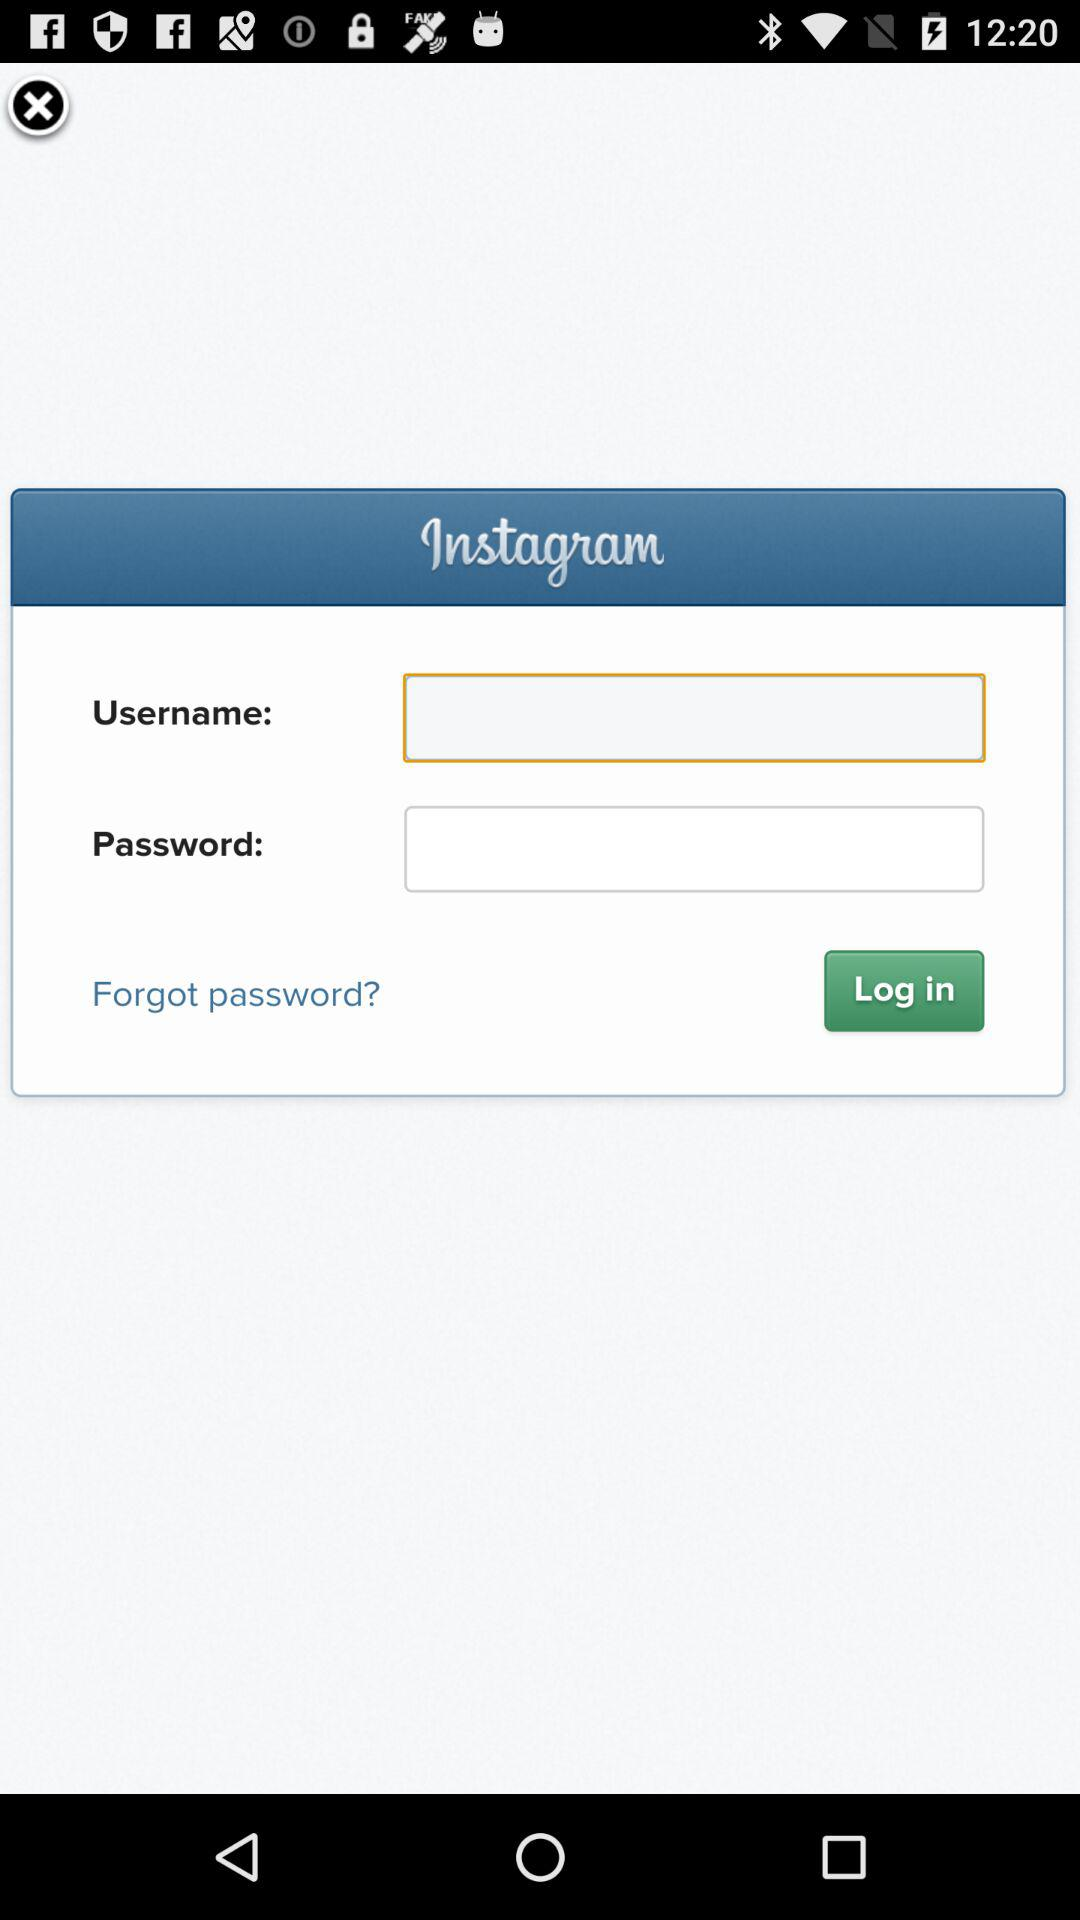What is the application name? The application name is "Instagram". 